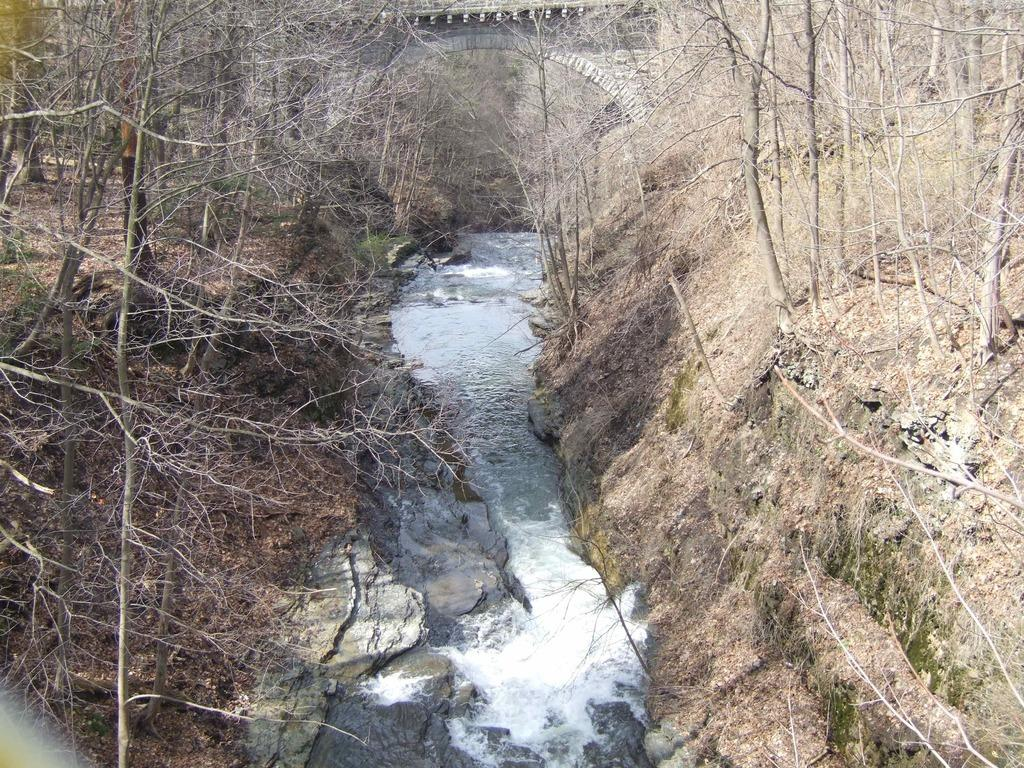What type of vegetation can be seen in the image? There is grass and trees in the image. What natural element is present in the image? There is water in the image. What man-made structure is visible in the image? There is a bridge in the image. Can you determine the time of day the image was taken? The image was likely taken during the day, as there is no indication of darkness or artificial lighting. What type of crime is being committed in the image? There is no indication of any crime being committed in the image. Can you hear any thunder in the image? The image is silent, and there is no indication of thunder or any other sound. 